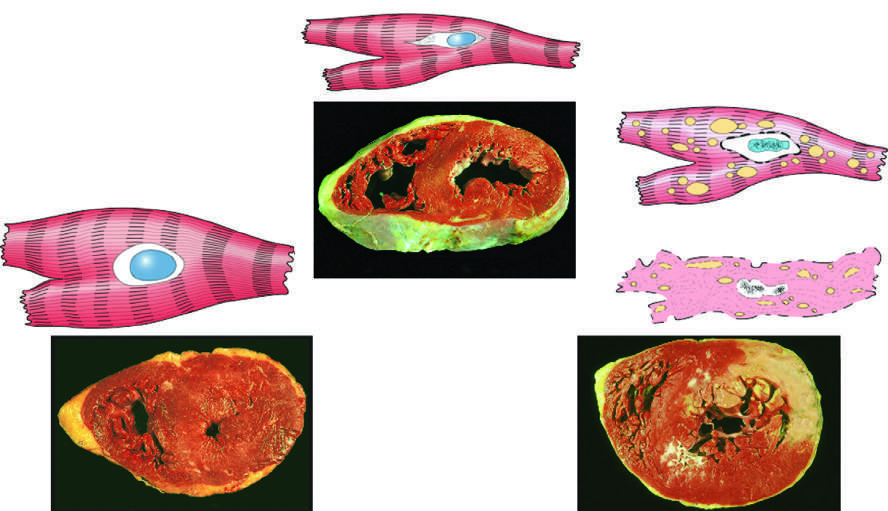what were all three transverse sections of myocardium stained with?
Answer the question using a single word or phrase. Triphenyltetra-zolium chloride 